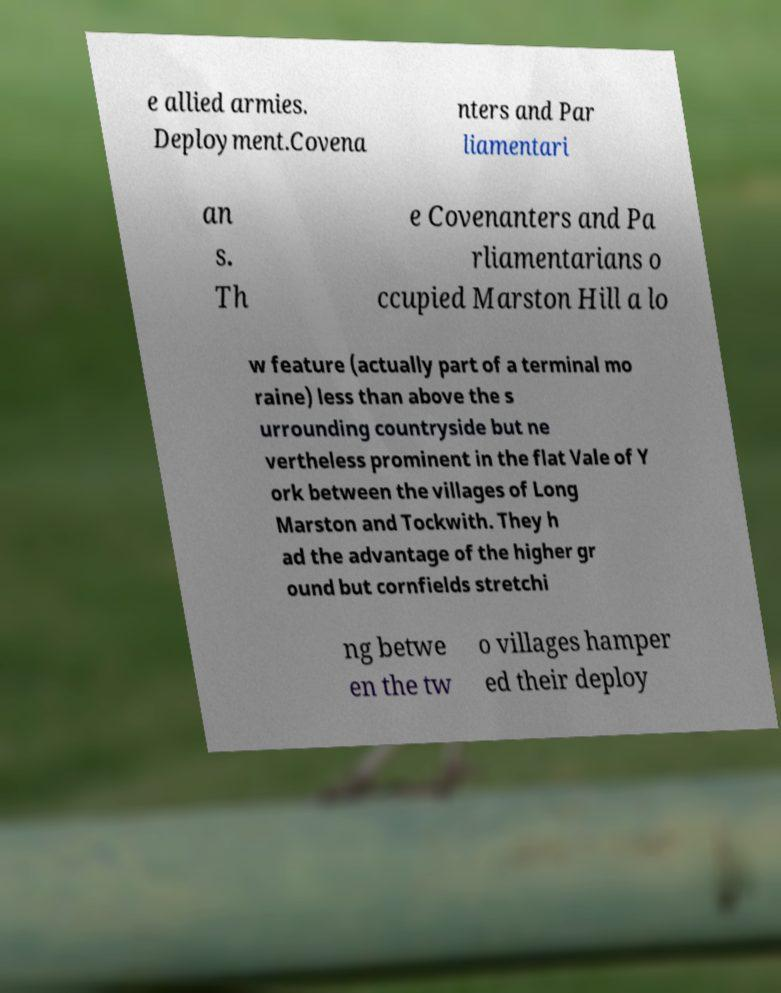What messages or text are displayed in this image? I need them in a readable, typed format. e allied armies. Deployment.Covena nters and Par liamentari an s. Th e Covenanters and Pa rliamentarians o ccupied Marston Hill a lo w feature (actually part of a terminal mo raine) less than above the s urrounding countryside but ne vertheless prominent in the flat Vale of Y ork between the villages of Long Marston and Tockwith. They h ad the advantage of the higher gr ound but cornfields stretchi ng betwe en the tw o villages hamper ed their deploy 